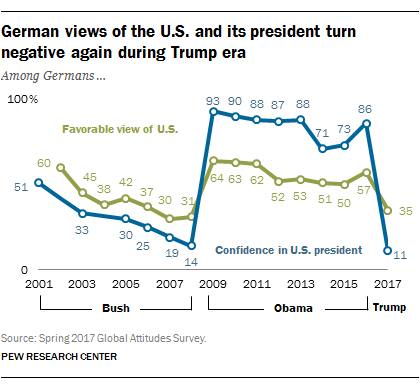Point out several critical features in this image. Of the values on the blue graph that are less than or equal to 20, how many are between 2 and 20, inclusive? The lowest value of blue in the graph is 11. 